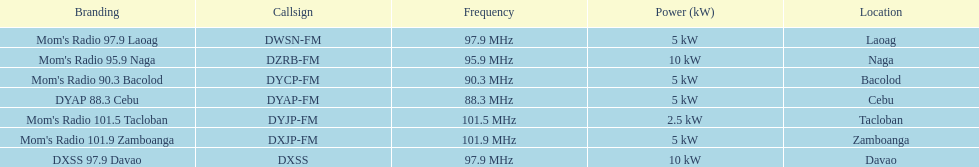What was the power in kilowatts of the davao radio? 10 kW. 